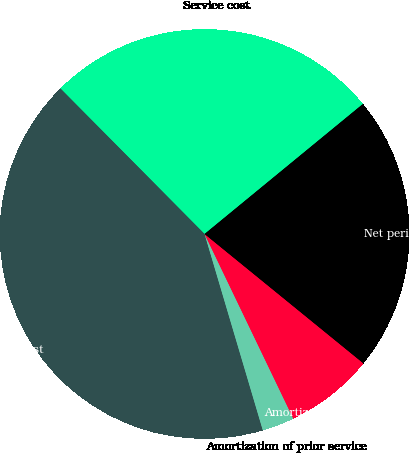<chart> <loc_0><loc_0><loc_500><loc_500><pie_chart><fcel>Service cost<fcel>Interest cost<fcel>Amortization of prior service<fcel>Amortization of net actuarial<fcel>Net periodic benefit cost<nl><fcel>26.48%<fcel>42.16%<fcel>2.54%<fcel>6.99%<fcel>21.82%<nl></chart> 